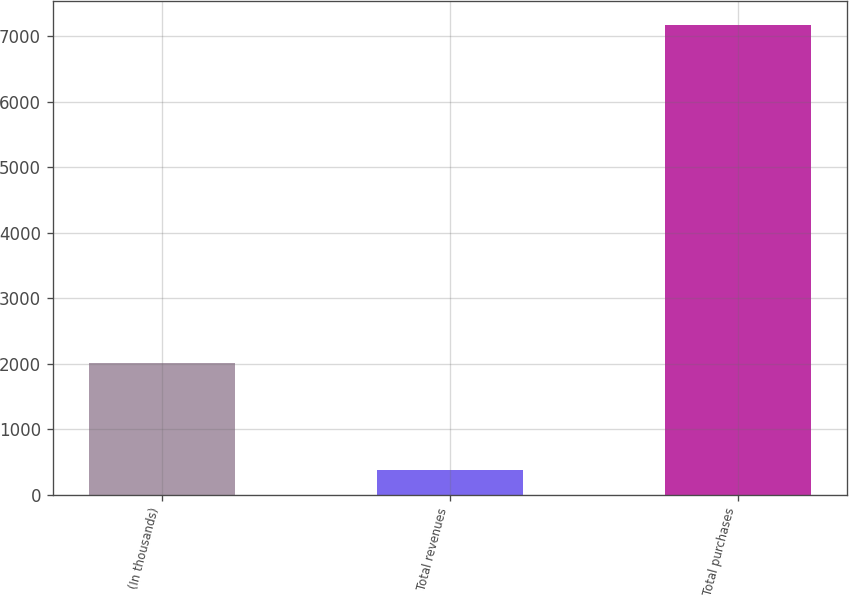Convert chart to OTSL. <chart><loc_0><loc_0><loc_500><loc_500><bar_chart><fcel>(In thousands)<fcel>Total revenues<fcel>Total purchases<nl><fcel>2011<fcel>379<fcel>7171<nl></chart> 